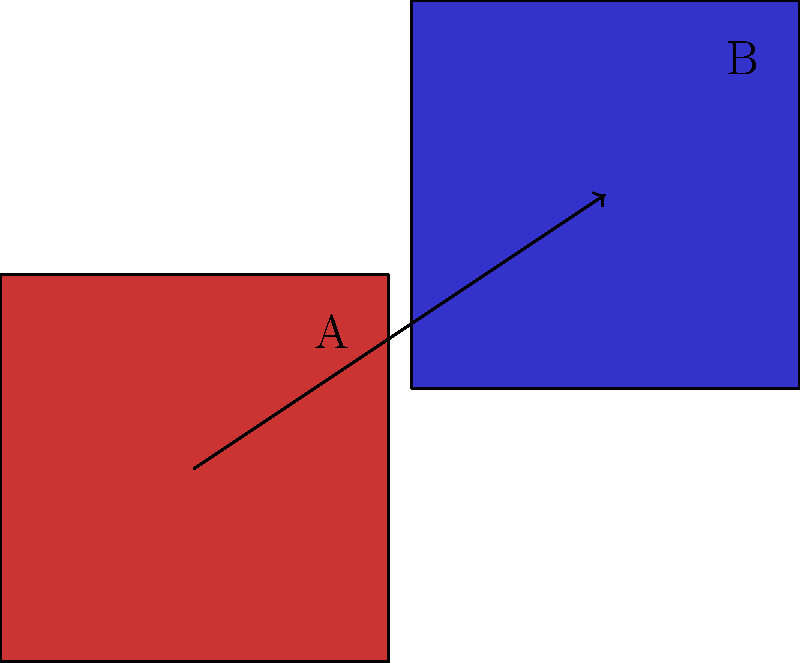In designing a dynamic floor pattern for a dance routine, you need to translate a square shape across the stage. If square A is translated to create square B, what is the translation vector that describes this transformation? To find the translation vector, we need to follow these steps:

1. Identify the corresponding points on squares A and B. In this case, we can use the bottom-left corners of each square.

2. The bottom-left corner of square A is at (0,0).

3. The bottom-left corner of square B is at (1.5,1).

4. To find the translation vector, we subtract the coordinates of the initial point from the coordinates of the final point:
   $$(1.5,1) - (0,0) = (1.5,1)$$

5. Therefore, the translation vector is $\langle 1.5, 1 \rangle$.

This vector represents the horizontal and vertical distances the square has moved. It can be interpreted as moving 1.5 units to the right and 1 unit up, which creates the dynamic movement in the floor pattern for the dance routine.
Answer: $\langle 1.5, 1 \rangle$ 